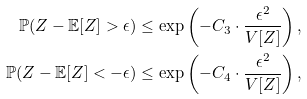Convert formula to latex. <formula><loc_0><loc_0><loc_500><loc_500>\mathbb { P } ( Z - \mathbb { E } [ Z ] > \epsilon ) \leq \exp \left ( - C _ { 3 } \cdot \frac { { \epsilon } ^ { 2 } } { V [ Z ] } \right ) , \\ \mathbb { P } ( Z - \mathbb { E } [ Z ] < - \epsilon ) \leq \exp \left ( - C _ { 4 } \cdot \frac { { \epsilon } ^ { 2 } } { V [ Z ] } \right ) ,</formula> 